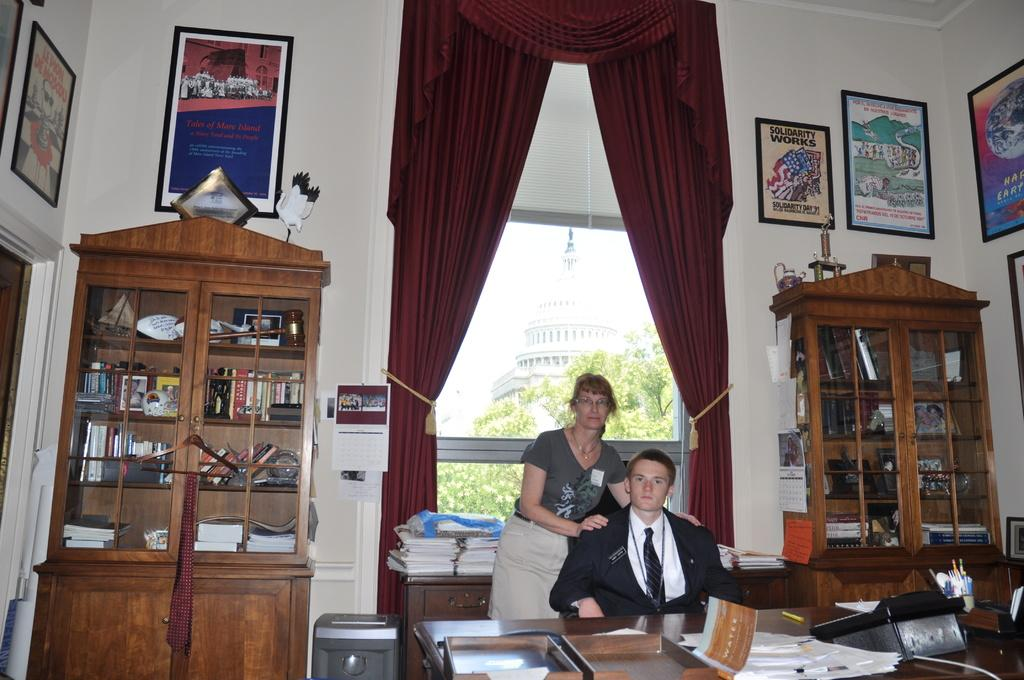What is the person in the image doing? The person is sitting on a chair in the image. Who is standing near the person? There is a woman standing beside the person. What type of furniture is present in the image? There is a wooden table in the image. What can be seen on the window in the image? There is a window glass in the image. What type of window treatment is present in the image? There is a curtain in the image. Reasoning: Let's think step by step by step in order to produce the conversation. We start by identifying the main subjects in the image, which are the person sitting on a chair and the woman standing beside them. Then, we expand the conversation to include other items that are also visible, such as the wooden table, window glass, and curtain. Each question is designed to elicit a specific detail about the image that is known from the provided facts. Absurd Question/Answer: What type of pizzas are being served on the van in the image? There is no van or pizzas present in the image; it features a person sitting on a chair, a woman standing beside them, a wooden table, a window glass, and a curtain. 